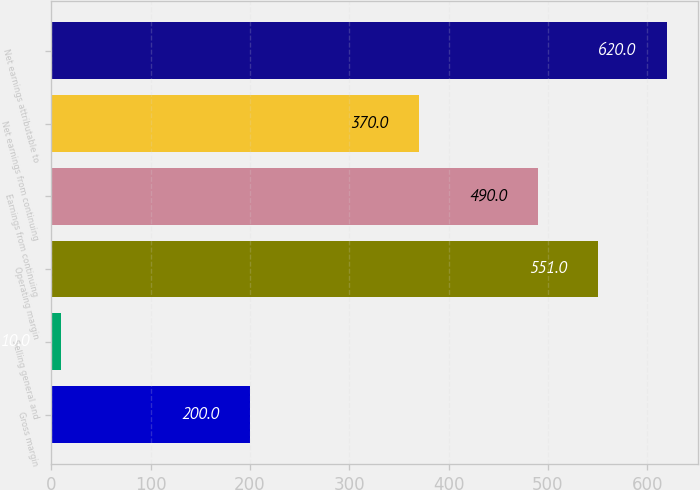Convert chart. <chart><loc_0><loc_0><loc_500><loc_500><bar_chart><fcel>Gross margin<fcel>Selling general and<fcel>Operating margin<fcel>Earnings from continuing<fcel>Net earnings from continuing<fcel>Net earnings attributable to<nl><fcel>200<fcel>10<fcel>551<fcel>490<fcel>370<fcel>620<nl></chart> 